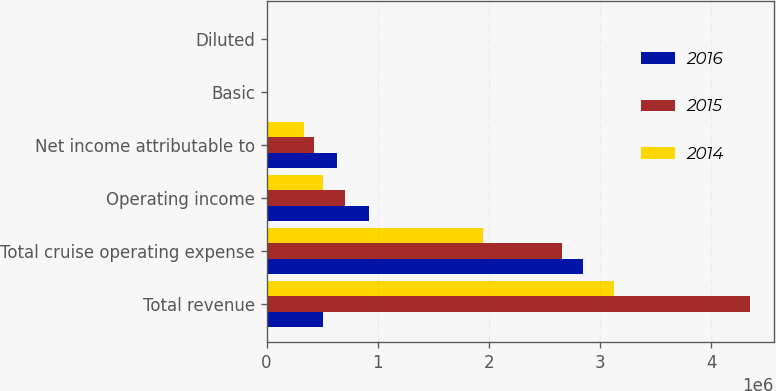Convert chart. <chart><loc_0><loc_0><loc_500><loc_500><stacked_bar_chart><ecel><fcel>Total revenue<fcel>Total cruise operating expense<fcel>Operating income<fcel>Net income attributable to<fcel>Basic<fcel>Diluted<nl><fcel>2016<fcel>502941<fcel>2.85022e+06<fcel>925464<fcel>633085<fcel>2.79<fcel>2.78<nl><fcel>2015<fcel>4.34505e+06<fcel>2.65545e+06<fcel>702486<fcel>427137<fcel>1.89<fcel>1.86<nl><fcel>2014<fcel>3.12588e+06<fcel>1.94662e+06<fcel>502941<fcel>338352<fcel>1.64<fcel>1.62<nl></chart> 